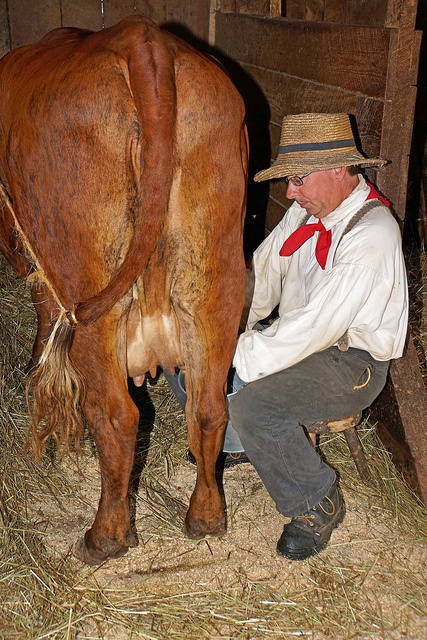Describe the objects in this image and their specific colors. I can see cow in black, brown, maroon, and gray tones, people in black, gray, and lightgray tones, and chair in black, gray, and maroon tones in this image. 